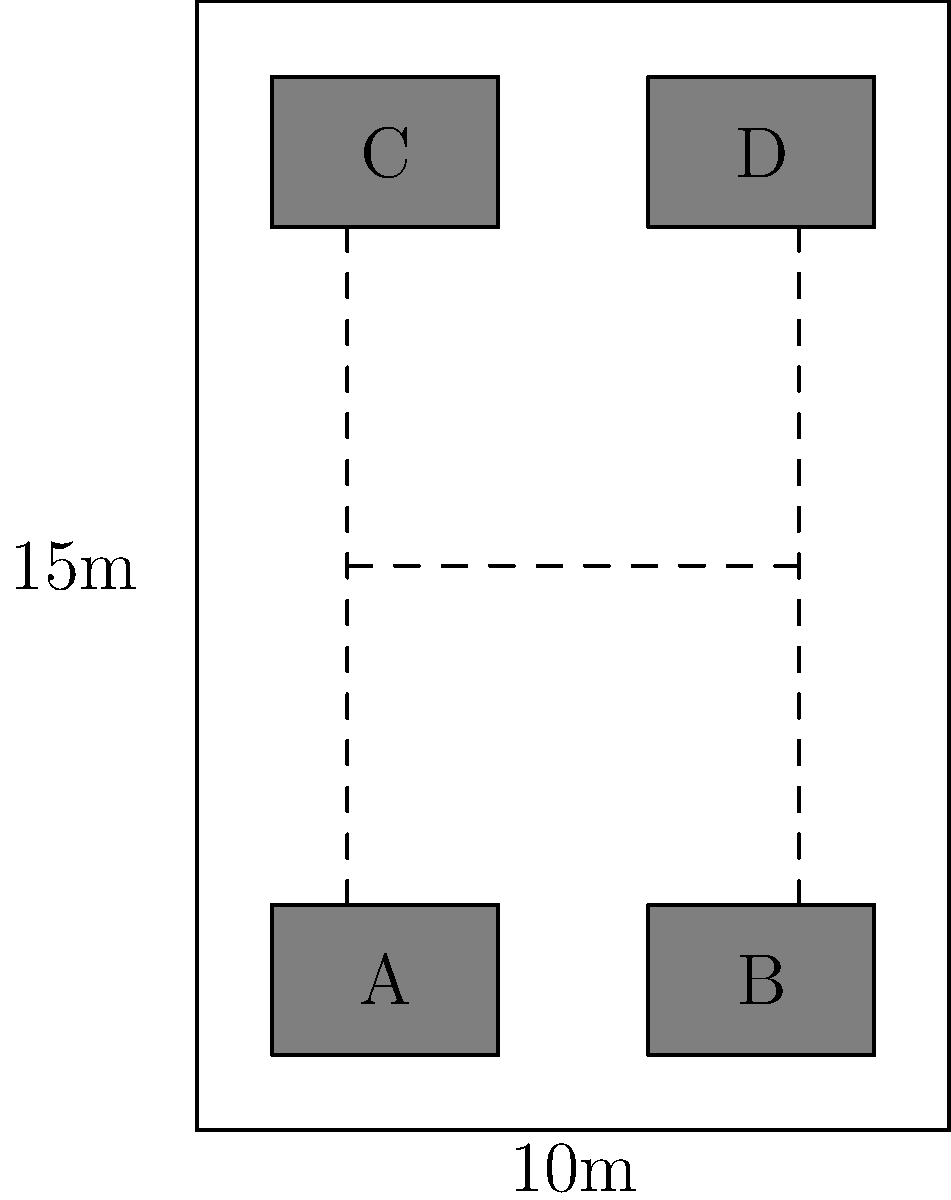Analyze the spatial efficiency of the given floor plan layout for a small office space. The room measures 10m x 15m and contains four workstations (labeled A, B, C, and D). Calculate the circulation area percentage and determine if it falls within the recommended range of 20-30% for efficient office layouts. To analyze the spatial efficiency and calculate the circulation area percentage, we'll follow these steps:

1. Calculate the total floor area:
   Total Area = 10m × 15m = 150 m²

2. Estimate the area occupied by workstations:
   Each workstation is approximately 3m × 2m = 6 m²
   Total workstation area = 4 × 6 m² = 24 m²

3. Calculate the circulation area:
   Circulation area = Total Area - Workstation Area
   Circulation area = 150 m² - 24 m² = 126 m²

4. Calculate the circulation area percentage:
   Circulation area percentage = (Circulation area / Total Area) × 100
   Circulation area percentage = (126 m² / 150 m²) × 100 = 84%

5. Compare the result to the recommended range:
   The calculated circulation area percentage (84%) is significantly higher than the recommended range of 20-30% for efficient office layouts.

6. Analyze the efficiency:
   This layout is not spatially efficient as it dedicates too much space to circulation, leaving a large amount of unused area. To improve efficiency, the layout could be redesigned to include more workstations or functional areas while maintaining adequate circulation space.
Answer: 84% circulation area; inefficient layout 